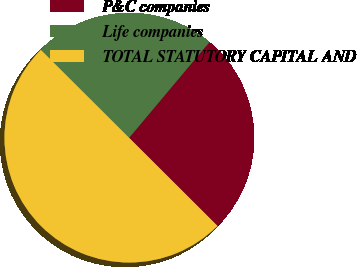Convert chart to OTSL. <chart><loc_0><loc_0><loc_500><loc_500><pie_chart><fcel>P&C companies<fcel>Life companies<fcel>TOTAL STATUTORY CAPITAL AND<nl><fcel>26.37%<fcel>23.63%<fcel>50.0%<nl></chart> 